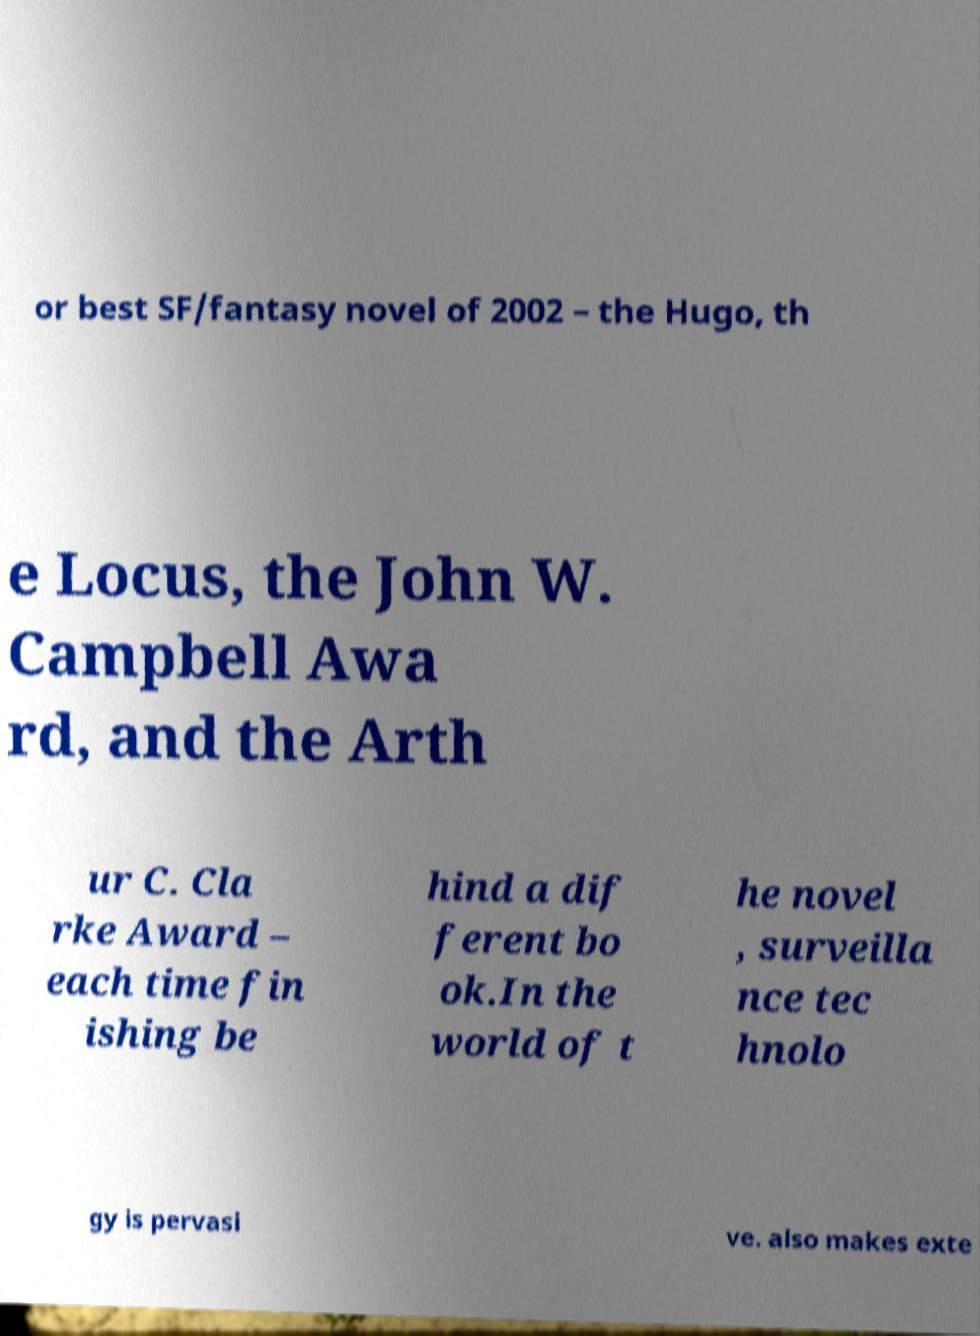For documentation purposes, I need the text within this image transcribed. Could you provide that? or best SF/fantasy novel of 2002 – the Hugo, th e Locus, the John W. Campbell Awa rd, and the Arth ur C. Cla rke Award – each time fin ishing be hind a dif ferent bo ok.In the world of t he novel , surveilla nce tec hnolo gy is pervasi ve. also makes exte 